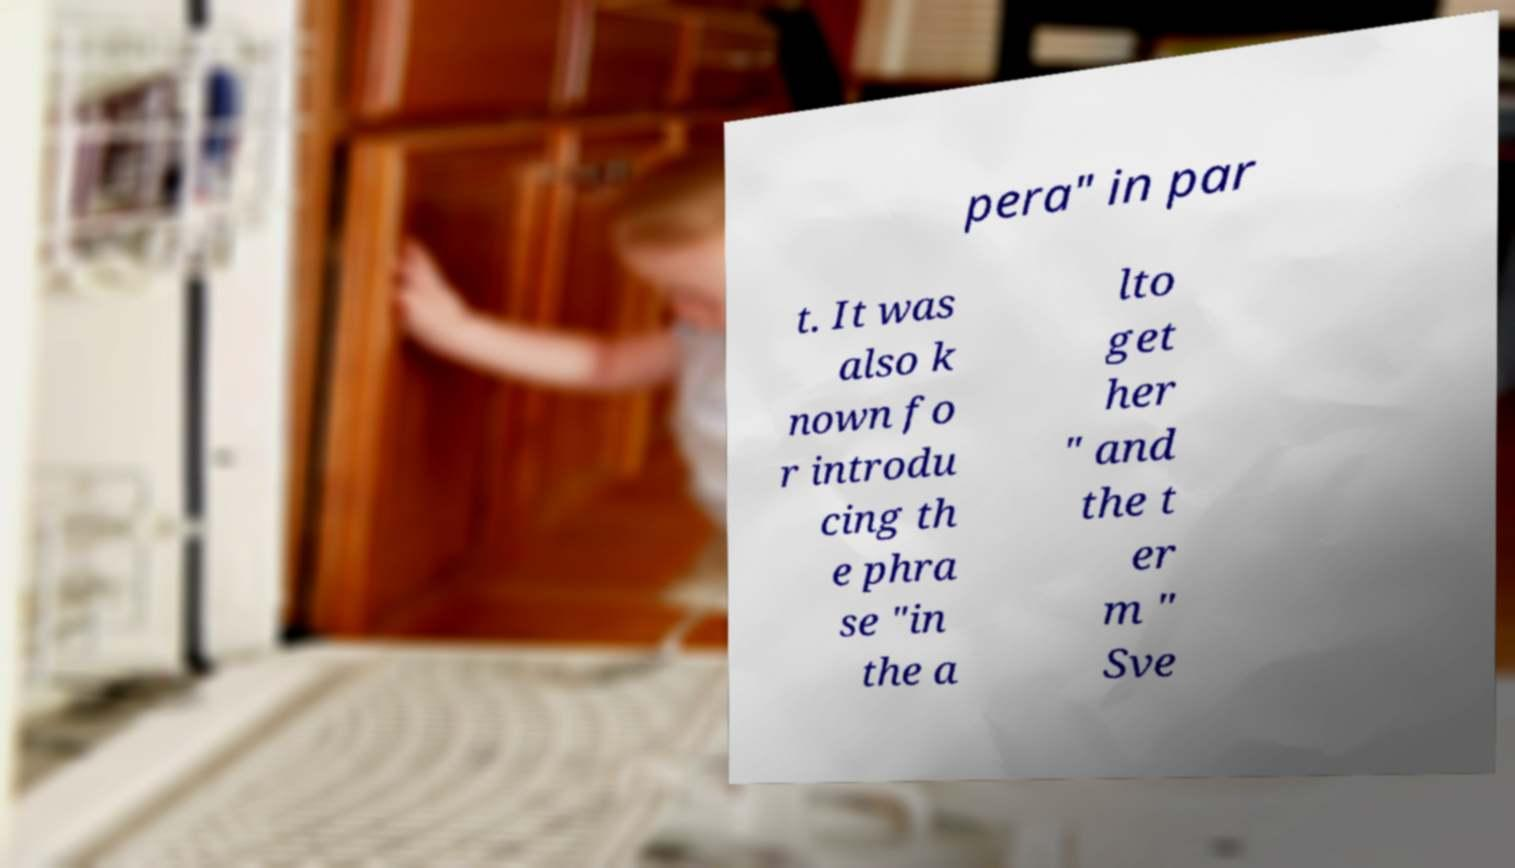For documentation purposes, I need the text within this image transcribed. Could you provide that? pera" in par t. It was also k nown fo r introdu cing th e phra se "in the a lto get her " and the t er m " Sve 